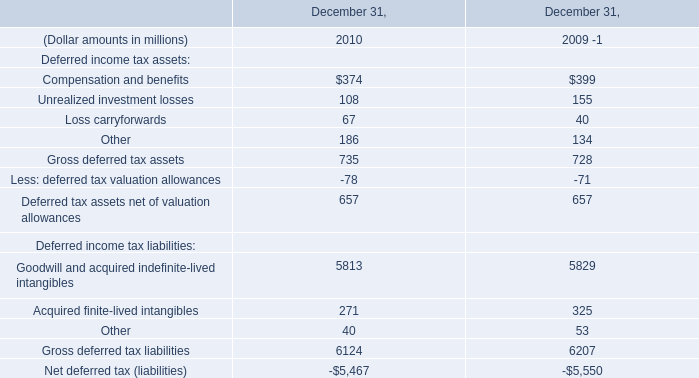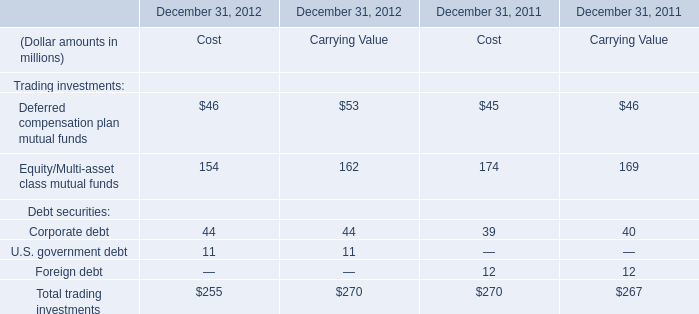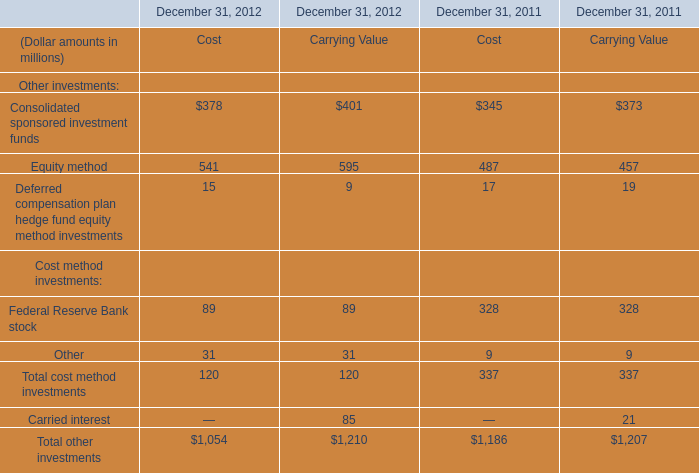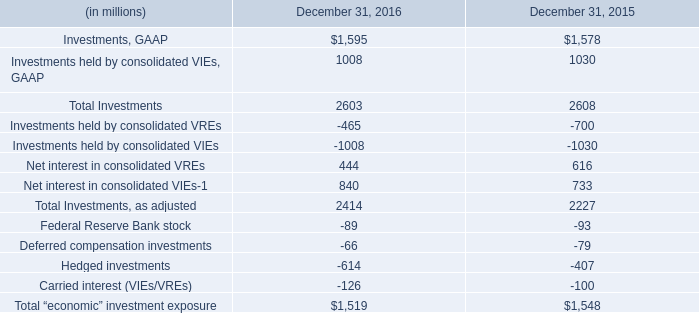What will Equity method of cost be like in 2013 if it develops with the same increasing rate as current? (in million) 
Computations: ((1 + ((541 - 487) / 487)) * 541)
Answer: 600.98768. 